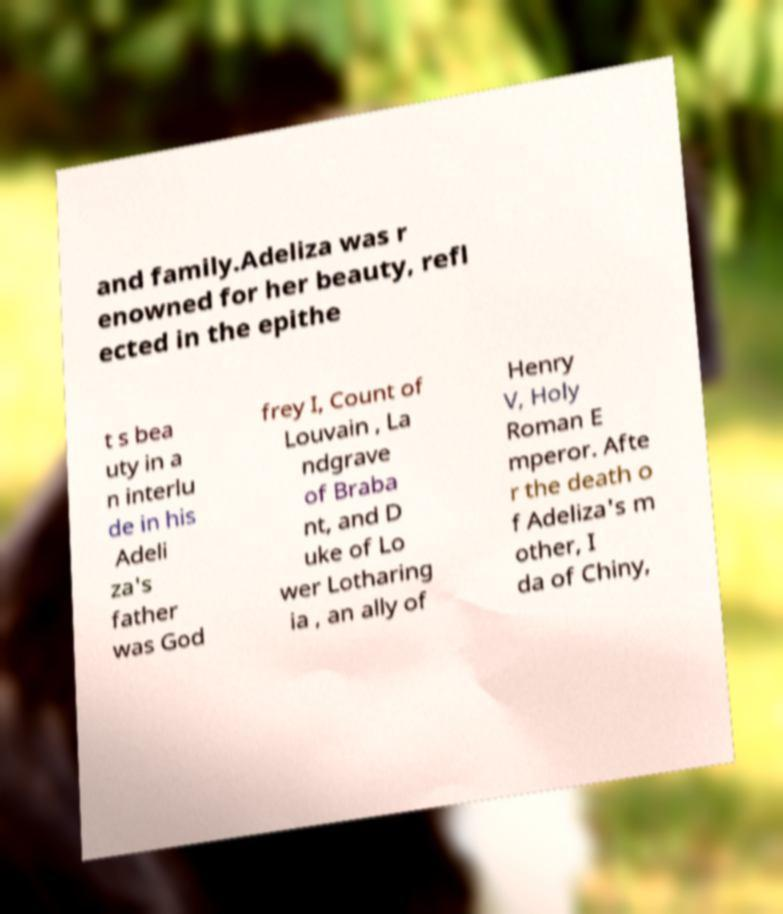Could you extract and type out the text from this image? and family.Adeliza was r enowned for her beauty, refl ected in the epithe t s bea uty in a n interlu de in his Adeli za's father was God frey I, Count of Louvain , La ndgrave of Braba nt, and D uke of Lo wer Lotharing ia , an ally of Henry V, Holy Roman E mperor. Afte r the death o f Adeliza's m other, I da of Chiny, 